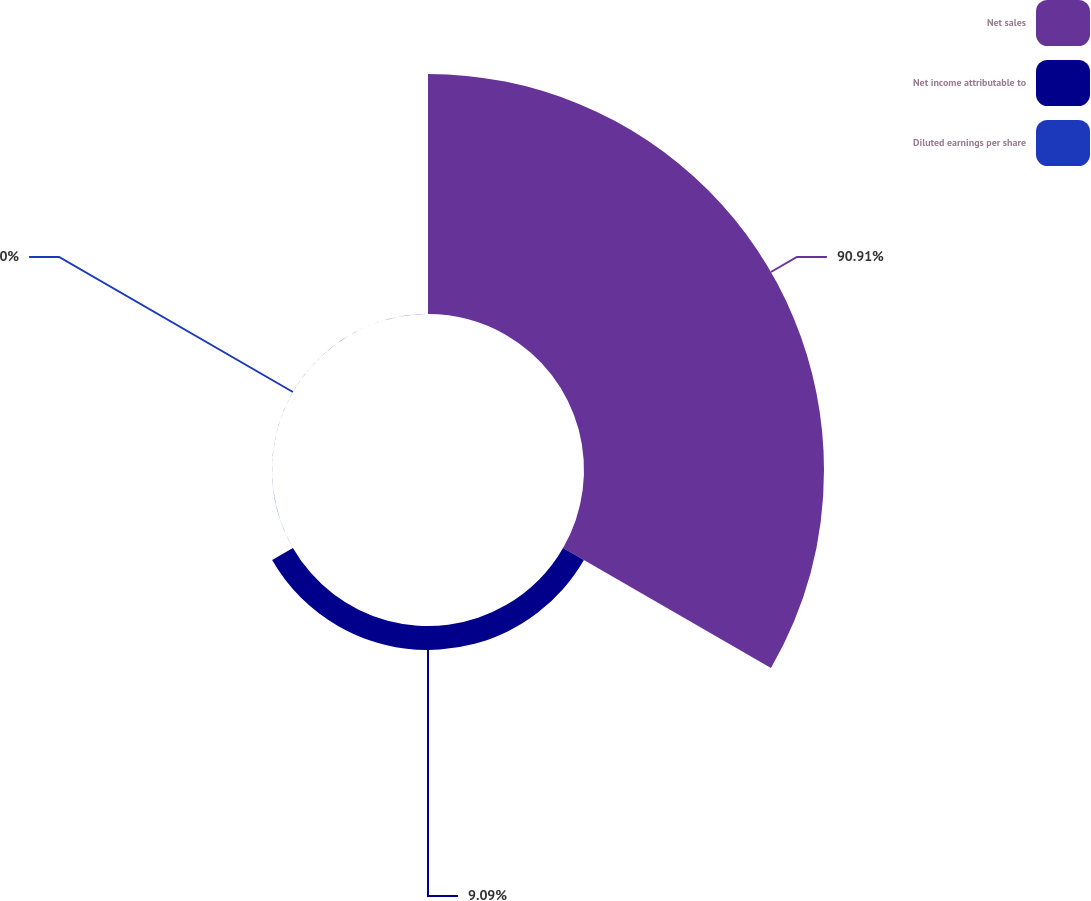Convert chart. <chart><loc_0><loc_0><loc_500><loc_500><pie_chart><fcel>Net sales<fcel>Net income attributable to<fcel>Diluted earnings per share<nl><fcel>90.91%<fcel>9.09%<fcel>0.0%<nl></chart> 